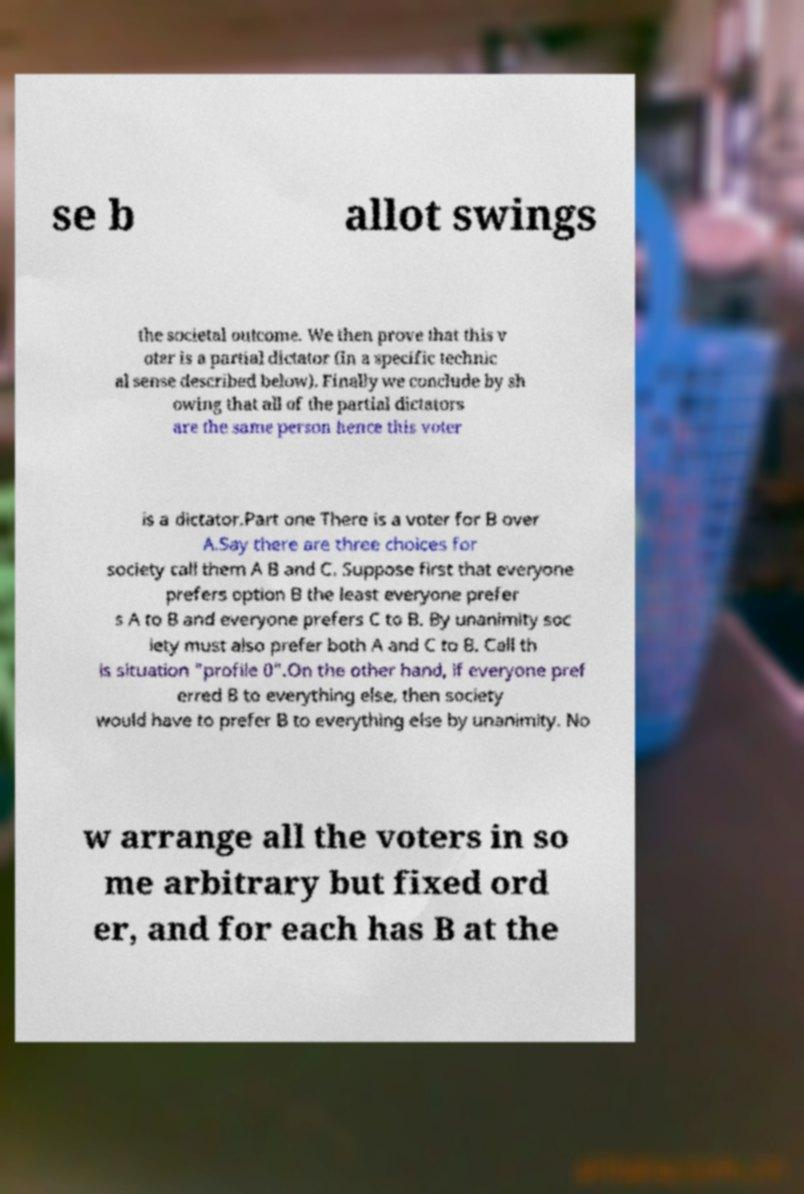Please read and relay the text visible in this image. What does it say? se b allot swings the societal outcome. We then prove that this v oter is a partial dictator (in a specific technic al sense described below). Finally we conclude by sh owing that all of the partial dictators are the same person hence this voter is a dictator.Part one There is a voter for B over A.Say there are three choices for society call them A B and C. Suppose first that everyone prefers option B the least everyone prefer s A to B and everyone prefers C to B. By unanimity soc iety must also prefer both A and C to B. Call th is situation "profile 0".On the other hand, if everyone pref erred B to everything else, then society would have to prefer B to everything else by unanimity. No w arrange all the voters in so me arbitrary but fixed ord er, and for each has B at the 